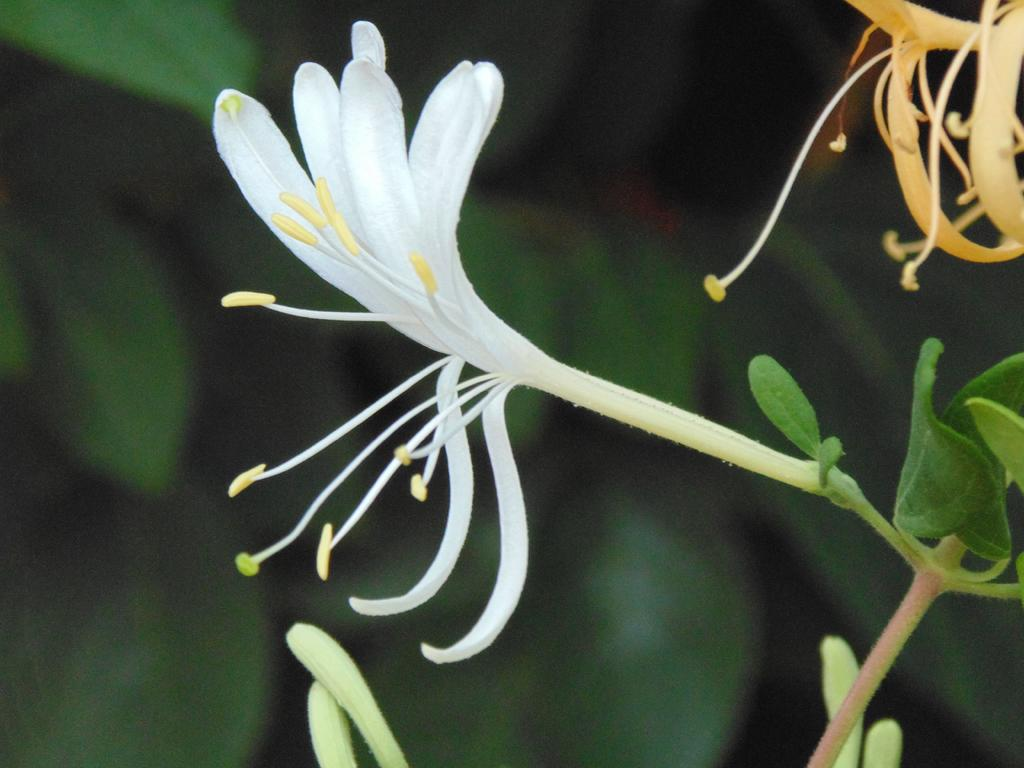What is the main subject of the image? There is a white flower in the middle of the image. Where are the leaves located in the image? There are leaves on the right side of the image. What can be seen in the background of the image? There are big green leaves in the background of the image. What type of plastic material is used to create the frame around the image? There is no frame present in the image, so it is not possible to determine the type of plastic material used. 